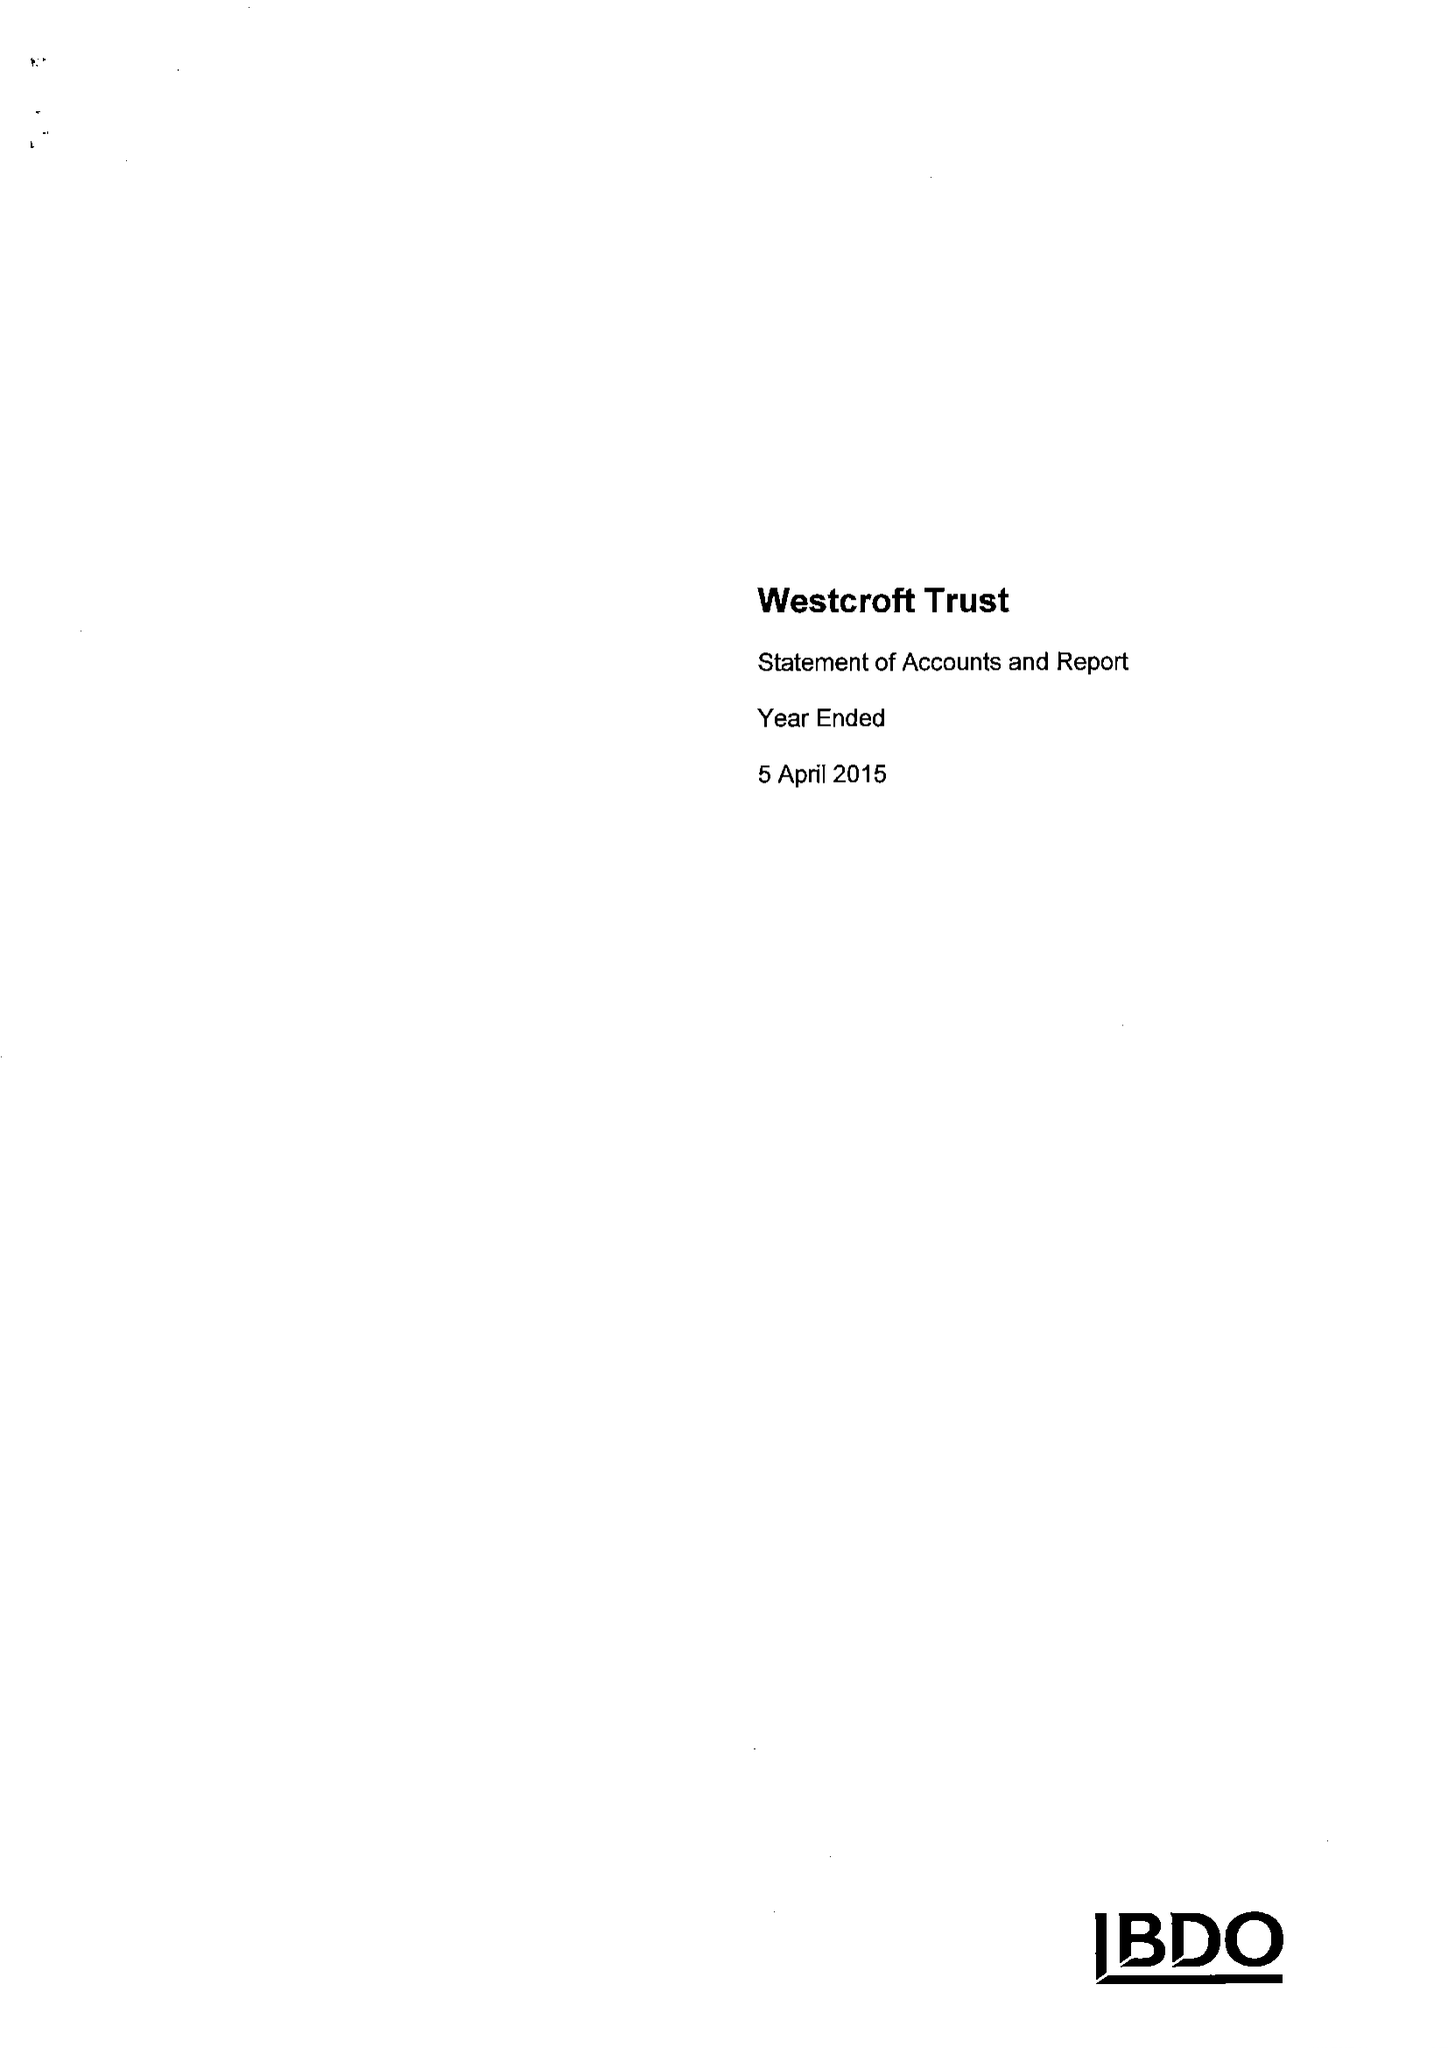What is the value for the address__post_town?
Answer the question using a single word or phrase. OSWESTRY 